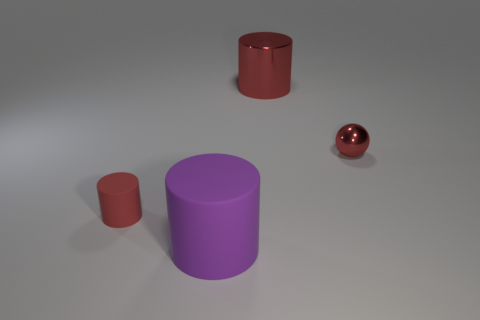The other tiny cylinder that is the same material as the purple cylinder is what color?
Your answer should be compact. Red. Is there anything else that is the same size as the red matte thing?
Your response must be concise. Yes. There is a tiny red shiny ball; what number of small red metallic objects are behind it?
Provide a succinct answer. 0. Is the color of the big shiny cylinder to the left of the tiny red metal sphere the same as the rubber cylinder that is on the left side of the large purple object?
Your answer should be very brief. Yes. There is a shiny object that is the same shape as the small red rubber object; what is its color?
Offer a very short reply. Red. Is there any other thing that is the same shape as the big red object?
Offer a very short reply. Yes. Is the shape of the big object that is to the left of the red metallic cylinder the same as the small object behind the tiny red matte object?
Offer a very short reply. No. There is a purple cylinder; does it have the same size as the red thing that is on the right side of the big red shiny cylinder?
Keep it short and to the point. No. Is the number of small red cylinders greater than the number of things?
Provide a succinct answer. No. Is the big purple object that is in front of the tiny red cylinder made of the same material as the object behind the small red sphere?
Your response must be concise. No. 